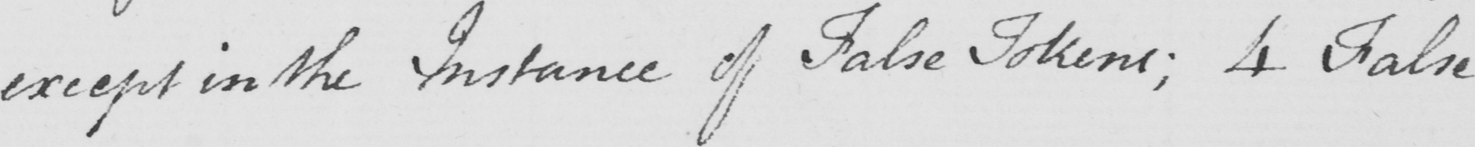What text is written in this handwritten line? except in the Instance of False Tokens ; 4 False 